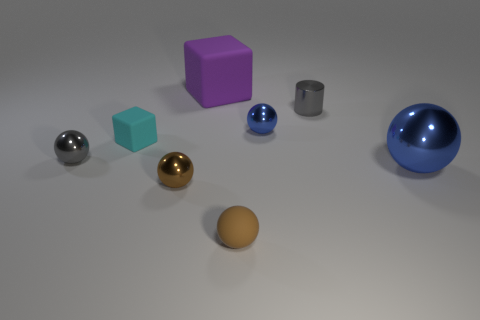Subtract all brown balls. How many balls are left? 3 Subtract 2 spheres. How many spheres are left? 3 Add 1 cylinders. How many objects exist? 9 Subtract all yellow balls. Subtract all cyan blocks. How many balls are left? 5 Subtract all brown rubber spheres. How many spheres are left? 4 Subtract all cylinders. How many objects are left? 7 Subtract all green blocks. Subtract all tiny cyan things. How many objects are left? 7 Add 1 cyan objects. How many cyan objects are left? 2 Add 5 tiny brown rubber spheres. How many tiny brown rubber spheres exist? 6 Subtract 1 purple cubes. How many objects are left? 7 